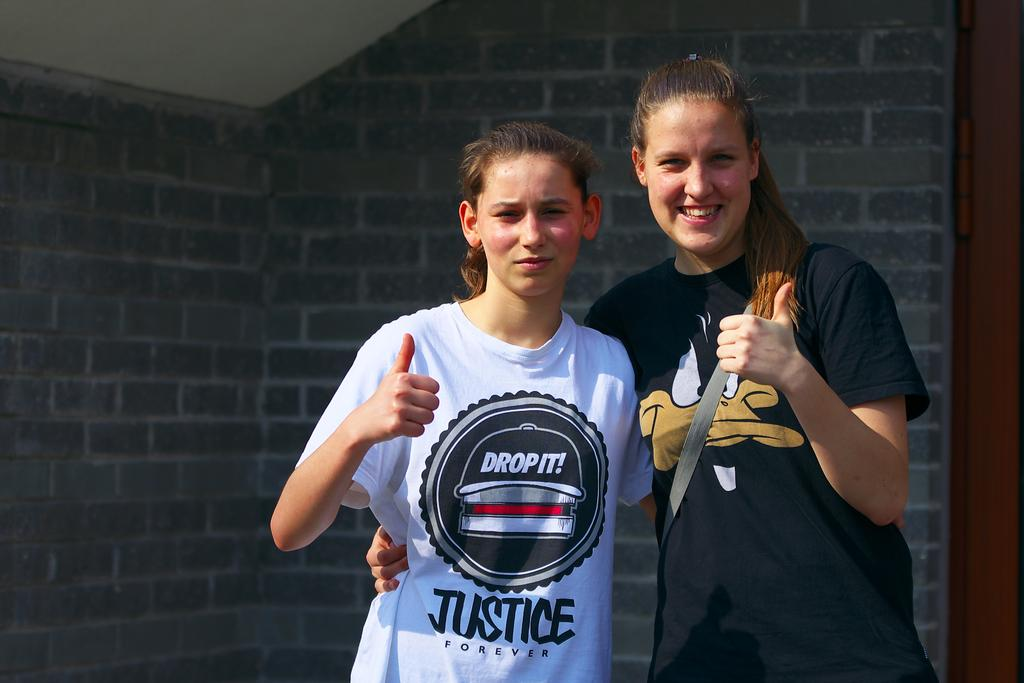Provide a one-sentence caption for the provided image. two girls give thumbs up signs while one wears a Drop It t-shirt. 